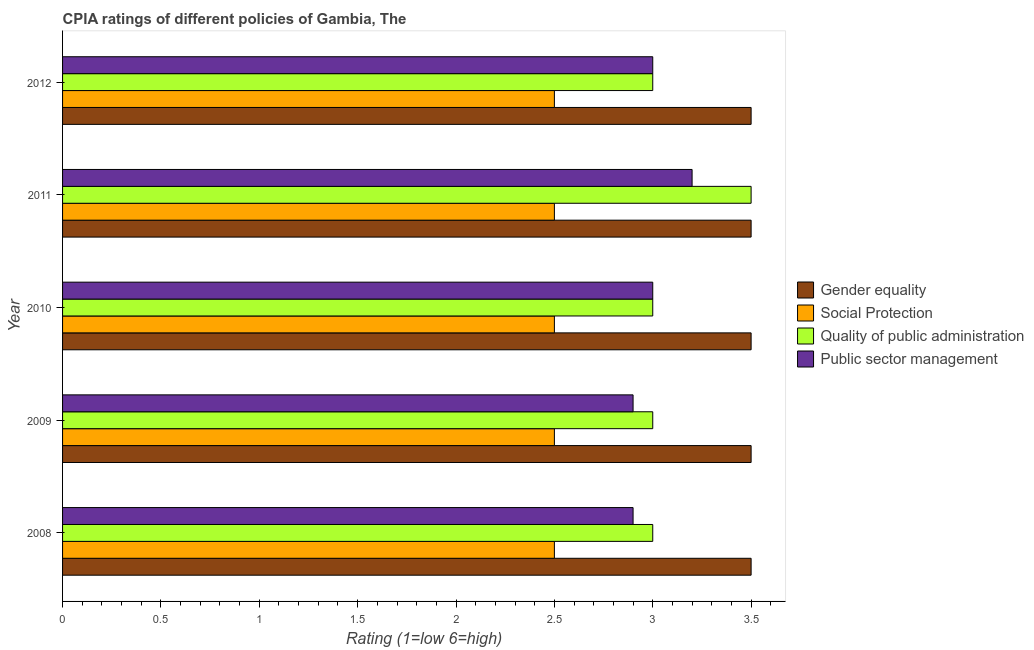How many groups of bars are there?
Offer a terse response. 5. Are the number of bars on each tick of the Y-axis equal?
Provide a succinct answer. Yes. How many bars are there on the 3rd tick from the top?
Offer a very short reply. 4. What is the label of the 2nd group of bars from the top?
Provide a short and direct response. 2011. What is the cpia rating of quality of public administration in 2010?
Your response must be concise. 3. Across all years, what is the maximum cpia rating of public sector management?
Your answer should be very brief. 3.2. What is the difference between the cpia rating of public sector management in 2009 and the cpia rating of quality of public administration in 2012?
Give a very brief answer. -0.1. In the year 2012, what is the difference between the cpia rating of social protection and cpia rating of public sector management?
Offer a terse response. -0.5. What is the ratio of the cpia rating of social protection in 2008 to that in 2011?
Offer a very short reply. 1. Is the cpia rating of public sector management in 2010 less than that in 2011?
Provide a succinct answer. Yes. Is the difference between the cpia rating of social protection in 2008 and 2010 greater than the difference between the cpia rating of gender equality in 2008 and 2010?
Ensure brevity in your answer.  No. What is the difference between the highest and the second highest cpia rating of social protection?
Provide a short and direct response. 0. What is the difference between the highest and the lowest cpia rating of social protection?
Provide a short and direct response. 0. In how many years, is the cpia rating of gender equality greater than the average cpia rating of gender equality taken over all years?
Provide a short and direct response. 0. Is the sum of the cpia rating of social protection in 2011 and 2012 greater than the maximum cpia rating of quality of public administration across all years?
Offer a very short reply. Yes. What does the 3rd bar from the top in 2012 represents?
Offer a terse response. Social Protection. What does the 1st bar from the bottom in 2010 represents?
Your answer should be very brief. Gender equality. Is it the case that in every year, the sum of the cpia rating of gender equality and cpia rating of social protection is greater than the cpia rating of quality of public administration?
Your answer should be very brief. Yes. How many bars are there?
Make the answer very short. 20. Are all the bars in the graph horizontal?
Make the answer very short. Yes. What is the difference between two consecutive major ticks on the X-axis?
Make the answer very short. 0.5. Does the graph contain any zero values?
Give a very brief answer. No. What is the title of the graph?
Keep it short and to the point. CPIA ratings of different policies of Gambia, The. What is the label or title of the X-axis?
Keep it short and to the point. Rating (1=low 6=high). What is the Rating (1=low 6=high) of Social Protection in 2008?
Give a very brief answer. 2.5. What is the Rating (1=low 6=high) of Quality of public administration in 2008?
Your answer should be very brief. 3. What is the Rating (1=low 6=high) of Public sector management in 2008?
Your answer should be compact. 2.9. What is the Rating (1=low 6=high) in Gender equality in 2009?
Your response must be concise. 3.5. What is the Rating (1=low 6=high) of Social Protection in 2009?
Keep it short and to the point. 2.5. What is the Rating (1=low 6=high) of Social Protection in 2010?
Your response must be concise. 2.5. What is the Rating (1=low 6=high) in Quality of public administration in 2010?
Your response must be concise. 3. What is the Rating (1=low 6=high) in Public sector management in 2010?
Your answer should be very brief. 3. What is the Rating (1=low 6=high) in Gender equality in 2011?
Keep it short and to the point. 3.5. What is the Rating (1=low 6=high) of Quality of public administration in 2011?
Your response must be concise. 3.5. What is the Rating (1=low 6=high) in Social Protection in 2012?
Make the answer very short. 2.5. What is the Rating (1=low 6=high) in Public sector management in 2012?
Ensure brevity in your answer.  3. Across all years, what is the maximum Rating (1=low 6=high) of Public sector management?
Give a very brief answer. 3.2. Across all years, what is the minimum Rating (1=low 6=high) in Gender equality?
Your answer should be compact. 3.5. Across all years, what is the minimum Rating (1=low 6=high) in Public sector management?
Provide a short and direct response. 2.9. What is the total Rating (1=low 6=high) of Social Protection in the graph?
Keep it short and to the point. 12.5. What is the total Rating (1=low 6=high) in Quality of public administration in the graph?
Provide a succinct answer. 15.5. What is the total Rating (1=low 6=high) in Public sector management in the graph?
Give a very brief answer. 15. What is the difference between the Rating (1=low 6=high) of Gender equality in 2008 and that in 2009?
Make the answer very short. 0. What is the difference between the Rating (1=low 6=high) in Quality of public administration in 2008 and that in 2009?
Make the answer very short. 0. What is the difference between the Rating (1=low 6=high) in Gender equality in 2008 and that in 2010?
Provide a succinct answer. 0. What is the difference between the Rating (1=low 6=high) in Quality of public administration in 2008 and that in 2010?
Your answer should be very brief. 0. What is the difference between the Rating (1=low 6=high) of Public sector management in 2008 and that in 2011?
Your response must be concise. -0.3. What is the difference between the Rating (1=low 6=high) of Social Protection in 2008 and that in 2012?
Give a very brief answer. 0. What is the difference between the Rating (1=low 6=high) in Public sector management in 2008 and that in 2012?
Offer a very short reply. -0.1. What is the difference between the Rating (1=low 6=high) of Social Protection in 2009 and that in 2010?
Offer a very short reply. 0. What is the difference between the Rating (1=low 6=high) in Public sector management in 2009 and that in 2010?
Your answer should be very brief. -0.1. What is the difference between the Rating (1=low 6=high) in Quality of public administration in 2009 and that in 2011?
Your answer should be compact. -0.5. What is the difference between the Rating (1=low 6=high) in Public sector management in 2009 and that in 2011?
Keep it short and to the point. -0.3. What is the difference between the Rating (1=low 6=high) of Social Protection in 2009 and that in 2012?
Make the answer very short. 0. What is the difference between the Rating (1=low 6=high) of Quality of public administration in 2009 and that in 2012?
Keep it short and to the point. 0. What is the difference between the Rating (1=low 6=high) of Social Protection in 2010 and that in 2011?
Offer a very short reply. 0. What is the difference between the Rating (1=low 6=high) of Gender equality in 2010 and that in 2012?
Keep it short and to the point. 0. What is the difference between the Rating (1=low 6=high) in Social Protection in 2010 and that in 2012?
Your answer should be compact. 0. What is the difference between the Rating (1=low 6=high) in Quality of public administration in 2010 and that in 2012?
Your response must be concise. 0. What is the difference between the Rating (1=low 6=high) of Social Protection in 2011 and that in 2012?
Make the answer very short. 0. What is the difference between the Rating (1=low 6=high) in Quality of public administration in 2011 and that in 2012?
Make the answer very short. 0.5. What is the difference between the Rating (1=low 6=high) in Gender equality in 2008 and the Rating (1=low 6=high) in Quality of public administration in 2009?
Offer a terse response. 0.5. What is the difference between the Rating (1=low 6=high) in Gender equality in 2008 and the Rating (1=low 6=high) in Public sector management in 2009?
Your answer should be compact. 0.6. What is the difference between the Rating (1=low 6=high) of Social Protection in 2008 and the Rating (1=low 6=high) of Public sector management in 2009?
Offer a terse response. -0.4. What is the difference between the Rating (1=low 6=high) in Quality of public administration in 2008 and the Rating (1=low 6=high) in Public sector management in 2009?
Provide a succinct answer. 0.1. What is the difference between the Rating (1=low 6=high) of Gender equality in 2008 and the Rating (1=low 6=high) of Social Protection in 2010?
Your response must be concise. 1. What is the difference between the Rating (1=low 6=high) of Social Protection in 2008 and the Rating (1=low 6=high) of Public sector management in 2010?
Provide a succinct answer. -0.5. What is the difference between the Rating (1=low 6=high) in Gender equality in 2008 and the Rating (1=low 6=high) in Quality of public administration in 2011?
Provide a short and direct response. 0. What is the difference between the Rating (1=low 6=high) in Social Protection in 2008 and the Rating (1=low 6=high) in Quality of public administration in 2011?
Your response must be concise. -1. What is the difference between the Rating (1=low 6=high) of Social Protection in 2008 and the Rating (1=low 6=high) of Public sector management in 2011?
Keep it short and to the point. -0.7. What is the difference between the Rating (1=low 6=high) of Gender equality in 2008 and the Rating (1=low 6=high) of Quality of public administration in 2012?
Give a very brief answer. 0.5. What is the difference between the Rating (1=low 6=high) of Gender equality in 2008 and the Rating (1=low 6=high) of Public sector management in 2012?
Your response must be concise. 0.5. What is the difference between the Rating (1=low 6=high) of Social Protection in 2008 and the Rating (1=low 6=high) of Quality of public administration in 2012?
Your answer should be very brief. -0.5. What is the difference between the Rating (1=low 6=high) of Gender equality in 2009 and the Rating (1=low 6=high) of Social Protection in 2010?
Offer a very short reply. 1. What is the difference between the Rating (1=low 6=high) of Gender equality in 2009 and the Rating (1=low 6=high) of Social Protection in 2011?
Your answer should be compact. 1. What is the difference between the Rating (1=low 6=high) in Gender equality in 2009 and the Rating (1=low 6=high) in Public sector management in 2011?
Make the answer very short. 0.3. What is the difference between the Rating (1=low 6=high) in Social Protection in 2009 and the Rating (1=low 6=high) in Quality of public administration in 2011?
Your answer should be compact. -1. What is the difference between the Rating (1=low 6=high) of Social Protection in 2009 and the Rating (1=low 6=high) of Public sector management in 2011?
Make the answer very short. -0.7. What is the difference between the Rating (1=low 6=high) of Social Protection in 2009 and the Rating (1=low 6=high) of Public sector management in 2012?
Keep it short and to the point. -0.5. What is the difference between the Rating (1=low 6=high) of Gender equality in 2010 and the Rating (1=low 6=high) of Social Protection in 2011?
Your response must be concise. 1. What is the difference between the Rating (1=low 6=high) of Social Protection in 2010 and the Rating (1=low 6=high) of Quality of public administration in 2011?
Ensure brevity in your answer.  -1. What is the difference between the Rating (1=low 6=high) in Social Protection in 2010 and the Rating (1=low 6=high) in Public sector management in 2011?
Provide a succinct answer. -0.7. What is the difference between the Rating (1=low 6=high) in Quality of public administration in 2010 and the Rating (1=low 6=high) in Public sector management in 2011?
Your response must be concise. -0.2. What is the difference between the Rating (1=low 6=high) in Social Protection in 2010 and the Rating (1=low 6=high) in Public sector management in 2012?
Your answer should be compact. -0.5. What is the difference between the Rating (1=low 6=high) of Gender equality in 2011 and the Rating (1=low 6=high) of Public sector management in 2012?
Your answer should be very brief. 0.5. What is the difference between the Rating (1=low 6=high) in Social Protection in 2011 and the Rating (1=low 6=high) in Quality of public administration in 2012?
Provide a short and direct response. -0.5. What is the average Rating (1=low 6=high) in Gender equality per year?
Provide a short and direct response. 3.5. In the year 2008, what is the difference between the Rating (1=low 6=high) in Social Protection and Rating (1=low 6=high) in Quality of public administration?
Offer a very short reply. -0.5. In the year 2009, what is the difference between the Rating (1=low 6=high) in Gender equality and Rating (1=low 6=high) in Social Protection?
Offer a terse response. 1. In the year 2009, what is the difference between the Rating (1=low 6=high) in Gender equality and Rating (1=low 6=high) in Quality of public administration?
Keep it short and to the point. 0.5. In the year 2009, what is the difference between the Rating (1=low 6=high) in Social Protection and Rating (1=low 6=high) in Public sector management?
Your answer should be very brief. -0.4. In the year 2009, what is the difference between the Rating (1=low 6=high) of Quality of public administration and Rating (1=low 6=high) of Public sector management?
Provide a short and direct response. 0.1. In the year 2010, what is the difference between the Rating (1=low 6=high) in Gender equality and Rating (1=low 6=high) in Quality of public administration?
Your answer should be very brief. 0.5. In the year 2011, what is the difference between the Rating (1=low 6=high) of Gender equality and Rating (1=low 6=high) of Social Protection?
Your answer should be very brief. 1. In the year 2011, what is the difference between the Rating (1=low 6=high) of Gender equality and Rating (1=low 6=high) of Quality of public administration?
Your answer should be very brief. 0. In the year 2011, what is the difference between the Rating (1=low 6=high) in Gender equality and Rating (1=low 6=high) in Public sector management?
Make the answer very short. 0.3. In the year 2011, what is the difference between the Rating (1=low 6=high) in Social Protection and Rating (1=low 6=high) in Quality of public administration?
Provide a succinct answer. -1. In the year 2011, what is the difference between the Rating (1=low 6=high) of Quality of public administration and Rating (1=low 6=high) of Public sector management?
Offer a terse response. 0.3. In the year 2012, what is the difference between the Rating (1=low 6=high) of Gender equality and Rating (1=low 6=high) of Social Protection?
Provide a short and direct response. 1. In the year 2012, what is the difference between the Rating (1=low 6=high) of Gender equality and Rating (1=low 6=high) of Quality of public administration?
Your answer should be compact. 0.5. In the year 2012, what is the difference between the Rating (1=low 6=high) in Gender equality and Rating (1=low 6=high) in Public sector management?
Make the answer very short. 0.5. What is the ratio of the Rating (1=low 6=high) in Gender equality in 2008 to that in 2009?
Your answer should be compact. 1. What is the ratio of the Rating (1=low 6=high) in Quality of public administration in 2008 to that in 2009?
Provide a succinct answer. 1. What is the ratio of the Rating (1=low 6=high) of Social Protection in 2008 to that in 2010?
Ensure brevity in your answer.  1. What is the ratio of the Rating (1=low 6=high) in Public sector management in 2008 to that in 2010?
Your answer should be very brief. 0.97. What is the ratio of the Rating (1=low 6=high) in Gender equality in 2008 to that in 2011?
Your answer should be very brief. 1. What is the ratio of the Rating (1=low 6=high) in Social Protection in 2008 to that in 2011?
Give a very brief answer. 1. What is the ratio of the Rating (1=low 6=high) in Quality of public administration in 2008 to that in 2011?
Ensure brevity in your answer.  0.86. What is the ratio of the Rating (1=low 6=high) in Public sector management in 2008 to that in 2011?
Ensure brevity in your answer.  0.91. What is the ratio of the Rating (1=low 6=high) in Gender equality in 2008 to that in 2012?
Make the answer very short. 1. What is the ratio of the Rating (1=low 6=high) of Social Protection in 2008 to that in 2012?
Offer a very short reply. 1. What is the ratio of the Rating (1=low 6=high) in Public sector management in 2008 to that in 2012?
Give a very brief answer. 0.97. What is the ratio of the Rating (1=low 6=high) of Quality of public administration in 2009 to that in 2010?
Your answer should be compact. 1. What is the ratio of the Rating (1=low 6=high) of Public sector management in 2009 to that in 2010?
Offer a very short reply. 0.97. What is the ratio of the Rating (1=low 6=high) of Gender equality in 2009 to that in 2011?
Ensure brevity in your answer.  1. What is the ratio of the Rating (1=low 6=high) of Quality of public administration in 2009 to that in 2011?
Offer a terse response. 0.86. What is the ratio of the Rating (1=low 6=high) of Public sector management in 2009 to that in 2011?
Provide a short and direct response. 0.91. What is the ratio of the Rating (1=low 6=high) of Social Protection in 2009 to that in 2012?
Make the answer very short. 1. What is the ratio of the Rating (1=low 6=high) of Quality of public administration in 2009 to that in 2012?
Provide a succinct answer. 1. What is the ratio of the Rating (1=low 6=high) of Public sector management in 2009 to that in 2012?
Your response must be concise. 0.97. What is the ratio of the Rating (1=low 6=high) in Gender equality in 2010 to that in 2011?
Give a very brief answer. 1. What is the ratio of the Rating (1=low 6=high) in Social Protection in 2010 to that in 2011?
Offer a very short reply. 1. What is the ratio of the Rating (1=low 6=high) of Quality of public administration in 2010 to that in 2011?
Your response must be concise. 0.86. What is the ratio of the Rating (1=low 6=high) in Public sector management in 2010 to that in 2011?
Make the answer very short. 0.94. What is the ratio of the Rating (1=low 6=high) in Gender equality in 2010 to that in 2012?
Make the answer very short. 1. What is the ratio of the Rating (1=low 6=high) in Public sector management in 2010 to that in 2012?
Make the answer very short. 1. What is the ratio of the Rating (1=low 6=high) of Quality of public administration in 2011 to that in 2012?
Your answer should be compact. 1.17. What is the ratio of the Rating (1=low 6=high) in Public sector management in 2011 to that in 2012?
Keep it short and to the point. 1.07. What is the difference between the highest and the second highest Rating (1=low 6=high) in Social Protection?
Your answer should be very brief. 0. What is the difference between the highest and the lowest Rating (1=low 6=high) of Social Protection?
Give a very brief answer. 0. What is the difference between the highest and the lowest Rating (1=low 6=high) in Quality of public administration?
Keep it short and to the point. 0.5. 